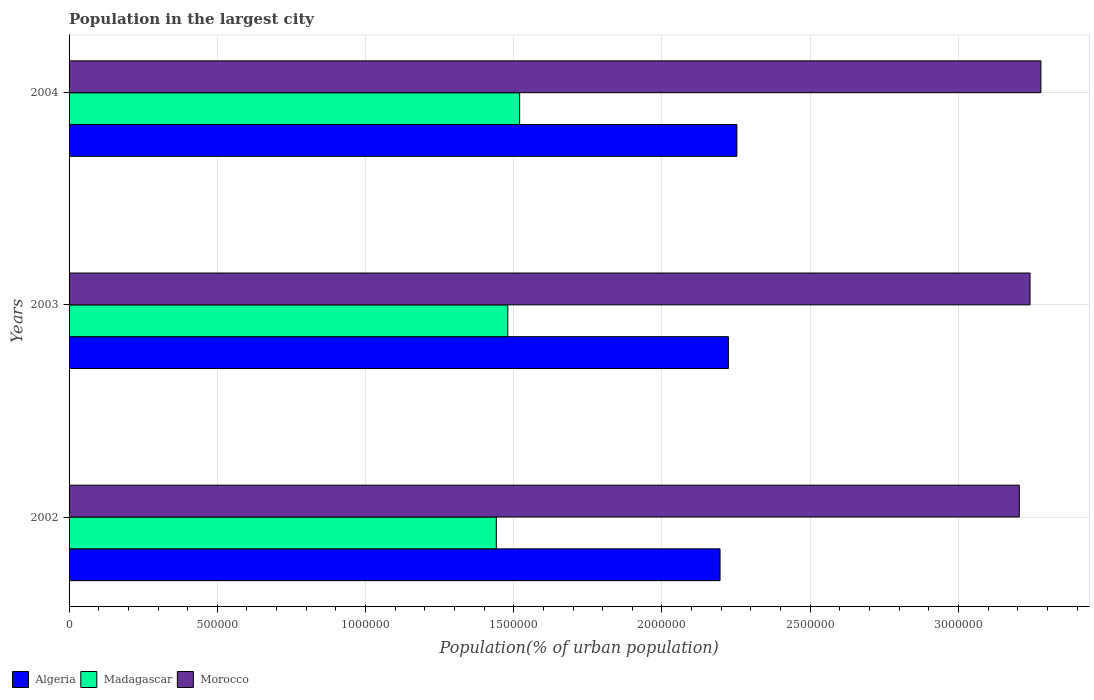How many different coloured bars are there?
Your response must be concise. 3. How many groups of bars are there?
Give a very brief answer. 3. Are the number of bars per tick equal to the number of legend labels?
Your answer should be compact. Yes. Are the number of bars on each tick of the Y-axis equal?
Give a very brief answer. Yes. How many bars are there on the 1st tick from the top?
Offer a very short reply. 3. How many bars are there on the 3rd tick from the bottom?
Keep it short and to the point. 3. What is the label of the 2nd group of bars from the top?
Offer a very short reply. 2003. In how many cases, is the number of bars for a given year not equal to the number of legend labels?
Make the answer very short. 0. What is the population in the largest city in Algeria in 2004?
Your response must be concise. 2.25e+06. Across all years, what is the maximum population in the largest city in Algeria?
Your response must be concise. 2.25e+06. Across all years, what is the minimum population in the largest city in Madagascar?
Provide a short and direct response. 1.44e+06. In which year was the population in the largest city in Algeria maximum?
Keep it short and to the point. 2004. In which year was the population in the largest city in Madagascar minimum?
Offer a very short reply. 2002. What is the total population in the largest city in Madagascar in the graph?
Your answer should be very brief. 4.44e+06. What is the difference between the population in the largest city in Madagascar in 2002 and that in 2004?
Keep it short and to the point. -7.87e+04. What is the difference between the population in the largest city in Algeria in 2004 and the population in the largest city in Morocco in 2002?
Provide a succinct answer. -9.53e+05. What is the average population in the largest city in Algeria per year?
Give a very brief answer. 2.22e+06. In the year 2004, what is the difference between the population in the largest city in Algeria and population in the largest city in Madagascar?
Offer a very short reply. 7.33e+05. In how many years, is the population in the largest city in Morocco greater than 900000 %?
Ensure brevity in your answer.  3. What is the ratio of the population in the largest city in Algeria in 2002 to that in 2004?
Your answer should be compact. 0.97. Is the population in the largest city in Morocco in 2003 less than that in 2004?
Keep it short and to the point. Yes. What is the difference between the highest and the second highest population in the largest city in Madagascar?
Make the answer very short. 3.99e+04. What is the difference between the highest and the lowest population in the largest city in Algeria?
Your response must be concise. 5.68e+04. In how many years, is the population in the largest city in Madagascar greater than the average population in the largest city in Madagascar taken over all years?
Your answer should be compact. 1. What does the 3rd bar from the top in 2002 represents?
Ensure brevity in your answer.  Algeria. What does the 3rd bar from the bottom in 2002 represents?
Provide a short and direct response. Morocco. Is it the case that in every year, the sum of the population in the largest city in Madagascar and population in the largest city in Morocco is greater than the population in the largest city in Algeria?
Provide a short and direct response. Yes. How many bars are there?
Provide a succinct answer. 9. Are all the bars in the graph horizontal?
Your response must be concise. Yes. How are the legend labels stacked?
Make the answer very short. Horizontal. What is the title of the graph?
Ensure brevity in your answer.  Population in the largest city. Does "Bolivia" appear as one of the legend labels in the graph?
Provide a succinct answer. No. What is the label or title of the X-axis?
Your response must be concise. Population(% of urban population). What is the Population(% of urban population) of Algeria in 2002?
Make the answer very short. 2.20e+06. What is the Population(% of urban population) of Madagascar in 2002?
Your response must be concise. 1.44e+06. What is the Population(% of urban population) in Morocco in 2002?
Offer a very short reply. 3.21e+06. What is the Population(% of urban population) of Algeria in 2003?
Give a very brief answer. 2.22e+06. What is the Population(% of urban population) of Madagascar in 2003?
Your answer should be very brief. 1.48e+06. What is the Population(% of urban population) in Morocco in 2003?
Give a very brief answer. 3.24e+06. What is the Population(% of urban population) of Algeria in 2004?
Provide a succinct answer. 2.25e+06. What is the Population(% of urban population) of Madagascar in 2004?
Make the answer very short. 1.52e+06. What is the Population(% of urban population) in Morocco in 2004?
Offer a very short reply. 3.28e+06. Across all years, what is the maximum Population(% of urban population) of Algeria?
Offer a terse response. 2.25e+06. Across all years, what is the maximum Population(% of urban population) of Madagascar?
Provide a short and direct response. 1.52e+06. Across all years, what is the maximum Population(% of urban population) of Morocco?
Your answer should be very brief. 3.28e+06. Across all years, what is the minimum Population(% of urban population) of Algeria?
Your answer should be compact. 2.20e+06. Across all years, what is the minimum Population(% of urban population) in Madagascar?
Your answer should be compact. 1.44e+06. Across all years, what is the minimum Population(% of urban population) in Morocco?
Make the answer very short. 3.21e+06. What is the total Population(% of urban population) in Algeria in the graph?
Make the answer very short. 6.67e+06. What is the total Population(% of urban population) of Madagascar in the graph?
Make the answer very short. 4.44e+06. What is the total Population(% of urban population) in Morocco in the graph?
Your answer should be very brief. 9.73e+06. What is the difference between the Population(% of urban population) of Algeria in 2002 and that in 2003?
Keep it short and to the point. -2.82e+04. What is the difference between the Population(% of urban population) in Madagascar in 2002 and that in 2003?
Give a very brief answer. -3.88e+04. What is the difference between the Population(% of urban population) in Morocco in 2002 and that in 2003?
Your response must be concise. -3.62e+04. What is the difference between the Population(% of urban population) in Algeria in 2002 and that in 2004?
Provide a succinct answer. -5.68e+04. What is the difference between the Population(% of urban population) in Madagascar in 2002 and that in 2004?
Offer a terse response. -7.87e+04. What is the difference between the Population(% of urban population) in Morocco in 2002 and that in 2004?
Make the answer very short. -7.28e+04. What is the difference between the Population(% of urban population) of Algeria in 2003 and that in 2004?
Ensure brevity in your answer.  -2.86e+04. What is the difference between the Population(% of urban population) in Madagascar in 2003 and that in 2004?
Provide a short and direct response. -3.99e+04. What is the difference between the Population(% of urban population) of Morocco in 2003 and that in 2004?
Keep it short and to the point. -3.66e+04. What is the difference between the Population(% of urban population) in Algeria in 2002 and the Population(% of urban population) in Madagascar in 2003?
Your response must be concise. 7.16e+05. What is the difference between the Population(% of urban population) in Algeria in 2002 and the Population(% of urban population) in Morocco in 2003?
Keep it short and to the point. -1.05e+06. What is the difference between the Population(% of urban population) of Madagascar in 2002 and the Population(% of urban population) of Morocco in 2003?
Keep it short and to the point. -1.80e+06. What is the difference between the Population(% of urban population) of Algeria in 2002 and the Population(% of urban population) of Madagascar in 2004?
Provide a succinct answer. 6.76e+05. What is the difference between the Population(% of urban population) in Algeria in 2002 and the Population(% of urban population) in Morocco in 2004?
Keep it short and to the point. -1.08e+06. What is the difference between the Population(% of urban population) of Madagascar in 2002 and the Population(% of urban population) of Morocco in 2004?
Provide a succinct answer. -1.84e+06. What is the difference between the Population(% of urban population) in Algeria in 2003 and the Population(% of urban population) in Madagascar in 2004?
Your answer should be very brief. 7.04e+05. What is the difference between the Population(% of urban population) of Algeria in 2003 and the Population(% of urban population) of Morocco in 2004?
Your answer should be compact. -1.05e+06. What is the difference between the Population(% of urban population) of Madagascar in 2003 and the Population(% of urban population) of Morocco in 2004?
Your answer should be very brief. -1.80e+06. What is the average Population(% of urban population) in Algeria per year?
Offer a very short reply. 2.22e+06. What is the average Population(% of urban population) of Madagascar per year?
Give a very brief answer. 1.48e+06. What is the average Population(% of urban population) of Morocco per year?
Provide a short and direct response. 3.24e+06. In the year 2002, what is the difference between the Population(% of urban population) of Algeria and Population(% of urban population) of Madagascar?
Provide a short and direct response. 7.55e+05. In the year 2002, what is the difference between the Population(% of urban population) in Algeria and Population(% of urban population) in Morocco?
Offer a very short reply. -1.01e+06. In the year 2002, what is the difference between the Population(% of urban population) in Madagascar and Population(% of urban population) in Morocco?
Your answer should be very brief. -1.76e+06. In the year 2003, what is the difference between the Population(% of urban population) of Algeria and Population(% of urban population) of Madagascar?
Offer a very short reply. 7.44e+05. In the year 2003, what is the difference between the Population(% of urban population) in Algeria and Population(% of urban population) in Morocco?
Make the answer very short. -1.02e+06. In the year 2003, what is the difference between the Population(% of urban population) in Madagascar and Population(% of urban population) in Morocco?
Your answer should be very brief. -1.76e+06. In the year 2004, what is the difference between the Population(% of urban population) in Algeria and Population(% of urban population) in Madagascar?
Give a very brief answer. 7.33e+05. In the year 2004, what is the difference between the Population(% of urban population) in Algeria and Population(% of urban population) in Morocco?
Your answer should be compact. -1.03e+06. In the year 2004, what is the difference between the Population(% of urban population) of Madagascar and Population(% of urban population) of Morocco?
Your response must be concise. -1.76e+06. What is the ratio of the Population(% of urban population) of Algeria in 2002 to that in 2003?
Provide a succinct answer. 0.99. What is the ratio of the Population(% of urban population) in Madagascar in 2002 to that in 2003?
Provide a short and direct response. 0.97. What is the ratio of the Population(% of urban population) of Morocco in 2002 to that in 2003?
Your answer should be compact. 0.99. What is the ratio of the Population(% of urban population) in Algeria in 2002 to that in 2004?
Provide a succinct answer. 0.97. What is the ratio of the Population(% of urban population) in Madagascar in 2002 to that in 2004?
Provide a succinct answer. 0.95. What is the ratio of the Population(% of urban population) of Morocco in 2002 to that in 2004?
Provide a short and direct response. 0.98. What is the ratio of the Population(% of urban population) in Algeria in 2003 to that in 2004?
Your answer should be very brief. 0.99. What is the ratio of the Population(% of urban population) in Madagascar in 2003 to that in 2004?
Provide a short and direct response. 0.97. What is the ratio of the Population(% of urban population) of Morocco in 2003 to that in 2004?
Your response must be concise. 0.99. What is the difference between the highest and the second highest Population(% of urban population) of Algeria?
Make the answer very short. 2.86e+04. What is the difference between the highest and the second highest Population(% of urban population) of Madagascar?
Ensure brevity in your answer.  3.99e+04. What is the difference between the highest and the second highest Population(% of urban population) of Morocco?
Provide a succinct answer. 3.66e+04. What is the difference between the highest and the lowest Population(% of urban population) of Algeria?
Your answer should be compact. 5.68e+04. What is the difference between the highest and the lowest Population(% of urban population) of Madagascar?
Provide a short and direct response. 7.87e+04. What is the difference between the highest and the lowest Population(% of urban population) in Morocco?
Provide a short and direct response. 7.28e+04. 